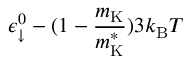Convert formula to latex. <formula><loc_0><loc_0><loc_500><loc_500>\epsilon _ { \downarrow } ^ { 0 } - ( 1 - \frac { m _ { K } } { m _ { K } ^ { * } } ) 3 k _ { B } T</formula> 